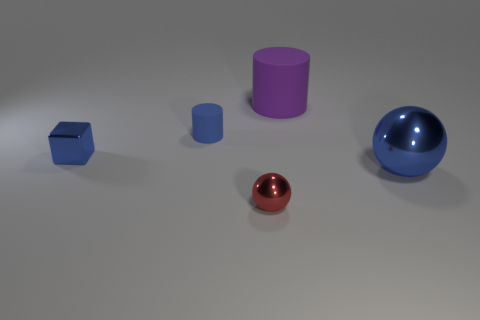Add 4 large brown rubber objects. How many objects exist? 9 Subtract all balls. How many objects are left? 3 Add 2 spheres. How many spheres exist? 4 Subtract 0 green cylinders. How many objects are left? 5 Subtract all small blue shiny cylinders. Subtract all tiny blue matte objects. How many objects are left? 4 Add 5 small cylinders. How many small cylinders are left? 6 